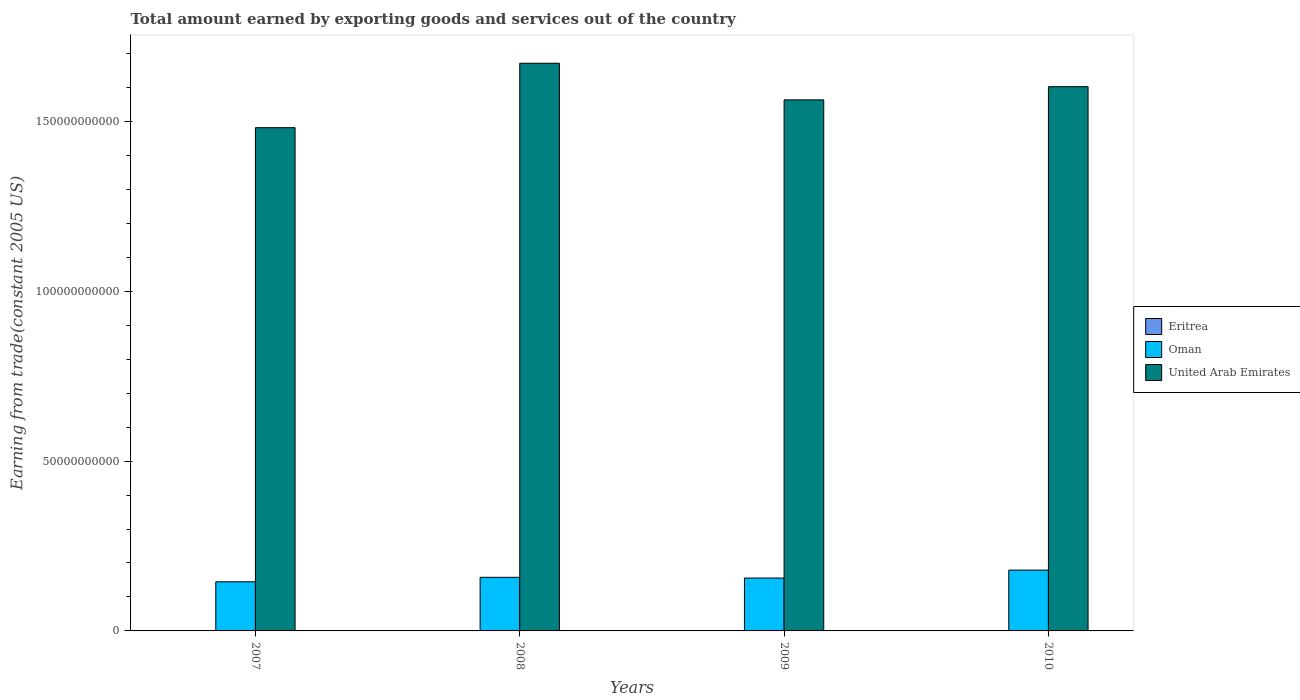How many groups of bars are there?
Offer a very short reply. 4. Are the number of bars per tick equal to the number of legend labels?
Ensure brevity in your answer.  Yes. How many bars are there on the 4th tick from the left?
Ensure brevity in your answer.  3. In how many cases, is the number of bars for a given year not equal to the number of legend labels?
Ensure brevity in your answer.  0. What is the total amount earned by exporting goods and services in United Arab Emirates in 2009?
Offer a terse response. 1.56e+11. Across all years, what is the maximum total amount earned by exporting goods and services in Oman?
Make the answer very short. 1.79e+1. Across all years, what is the minimum total amount earned by exporting goods and services in United Arab Emirates?
Make the answer very short. 1.48e+11. In which year was the total amount earned by exporting goods and services in United Arab Emirates minimum?
Provide a short and direct response. 2007. What is the total total amount earned by exporting goods and services in United Arab Emirates in the graph?
Your answer should be compact. 6.32e+11. What is the difference between the total amount earned by exporting goods and services in Eritrea in 2007 and that in 2008?
Your answer should be compact. 1.45e+07. What is the difference between the total amount earned by exporting goods and services in Oman in 2010 and the total amount earned by exporting goods and services in Eritrea in 2009?
Your answer should be very brief. 1.78e+1. What is the average total amount earned by exporting goods and services in Eritrea per year?
Provide a succinct answer. 6.97e+07. In the year 2009, what is the difference between the total amount earned by exporting goods and services in United Arab Emirates and total amount earned by exporting goods and services in Eritrea?
Your answer should be compact. 1.56e+11. What is the ratio of the total amount earned by exporting goods and services in Oman in 2009 to that in 2010?
Your answer should be very brief. 0.87. Is the total amount earned by exporting goods and services in United Arab Emirates in 2009 less than that in 2010?
Your answer should be compact. Yes. What is the difference between the highest and the second highest total amount earned by exporting goods and services in Eritrea?
Your response must be concise. 1.27e+07. What is the difference between the highest and the lowest total amount earned by exporting goods and services in Eritrea?
Offer a terse response. 3.20e+07. In how many years, is the total amount earned by exporting goods and services in United Arab Emirates greater than the average total amount earned by exporting goods and services in United Arab Emirates taken over all years?
Your response must be concise. 2. What does the 2nd bar from the left in 2009 represents?
Your response must be concise. Oman. What does the 1st bar from the right in 2009 represents?
Ensure brevity in your answer.  United Arab Emirates. How many bars are there?
Give a very brief answer. 12. Are all the bars in the graph horizontal?
Give a very brief answer. No. How many years are there in the graph?
Provide a short and direct response. 4. What is the difference between two consecutive major ticks on the Y-axis?
Ensure brevity in your answer.  5.00e+1. Are the values on the major ticks of Y-axis written in scientific E-notation?
Provide a succinct answer. No. Does the graph contain grids?
Your answer should be compact. No. Where does the legend appear in the graph?
Make the answer very short. Center right. How are the legend labels stacked?
Your answer should be compact. Vertical. What is the title of the graph?
Make the answer very short. Total amount earned by exporting goods and services out of the country. What is the label or title of the X-axis?
Offer a terse response. Years. What is the label or title of the Y-axis?
Provide a succinct answer. Earning from trade(constant 2005 US). What is the Earning from trade(constant 2005 US) of Eritrea in 2007?
Offer a terse response. 6.77e+07. What is the Earning from trade(constant 2005 US) of Oman in 2007?
Provide a succinct answer. 1.45e+1. What is the Earning from trade(constant 2005 US) in United Arab Emirates in 2007?
Your response must be concise. 1.48e+11. What is the Earning from trade(constant 2005 US) in Eritrea in 2008?
Your answer should be compact. 5.32e+07. What is the Earning from trade(constant 2005 US) of Oman in 2008?
Offer a terse response. 1.58e+1. What is the Earning from trade(constant 2005 US) of United Arab Emirates in 2008?
Provide a succinct answer. 1.67e+11. What is the Earning from trade(constant 2005 US) in Eritrea in 2009?
Provide a succinct answer. 7.25e+07. What is the Earning from trade(constant 2005 US) of Oman in 2009?
Provide a short and direct response. 1.56e+1. What is the Earning from trade(constant 2005 US) of United Arab Emirates in 2009?
Offer a terse response. 1.56e+11. What is the Earning from trade(constant 2005 US) in Eritrea in 2010?
Your answer should be very brief. 8.52e+07. What is the Earning from trade(constant 2005 US) of Oman in 2010?
Ensure brevity in your answer.  1.79e+1. What is the Earning from trade(constant 2005 US) in United Arab Emirates in 2010?
Offer a very short reply. 1.60e+11. Across all years, what is the maximum Earning from trade(constant 2005 US) in Eritrea?
Make the answer very short. 8.52e+07. Across all years, what is the maximum Earning from trade(constant 2005 US) in Oman?
Your answer should be compact. 1.79e+1. Across all years, what is the maximum Earning from trade(constant 2005 US) of United Arab Emirates?
Offer a terse response. 1.67e+11. Across all years, what is the minimum Earning from trade(constant 2005 US) of Eritrea?
Your response must be concise. 5.32e+07. Across all years, what is the minimum Earning from trade(constant 2005 US) of Oman?
Your answer should be very brief. 1.45e+1. Across all years, what is the minimum Earning from trade(constant 2005 US) in United Arab Emirates?
Provide a short and direct response. 1.48e+11. What is the total Earning from trade(constant 2005 US) of Eritrea in the graph?
Give a very brief answer. 2.79e+08. What is the total Earning from trade(constant 2005 US) in Oman in the graph?
Your response must be concise. 6.37e+1. What is the total Earning from trade(constant 2005 US) in United Arab Emirates in the graph?
Your response must be concise. 6.32e+11. What is the difference between the Earning from trade(constant 2005 US) of Eritrea in 2007 and that in 2008?
Give a very brief answer. 1.45e+07. What is the difference between the Earning from trade(constant 2005 US) in Oman in 2007 and that in 2008?
Offer a terse response. -1.32e+09. What is the difference between the Earning from trade(constant 2005 US) of United Arab Emirates in 2007 and that in 2008?
Your response must be concise. -1.90e+1. What is the difference between the Earning from trade(constant 2005 US) in Eritrea in 2007 and that in 2009?
Ensure brevity in your answer.  -4.81e+06. What is the difference between the Earning from trade(constant 2005 US) in Oman in 2007 and that in 2009?
Provide a succinct answer. -1.11e+09. What is the difference between the Earning from trade(constant 2005 US) in United Arab Emirates in 2007 and that in 2009?
Your response must be concise. -8.19e+09. What is the difference between the Earning from trade(constant 2005 US) in Eritrea in 2007 and that in 2010?
Provide a succinct answer. -1.75e+07. What is the difference between the Earning from trade(constant 2005 US) in Oman in 2007 and that in 2010?
Give a very brief answer. -3.44e+09. What is the difference between the Earning from trade(constant 2005 US) of United Arab Emirates in 2007 and that in 2010?
Your answer should be compact. -1.21e+1. What is the difference between the Earning from trade(constant 2005 US) of Eritrea in 2008 and that in 2009?
Offer a terse response. -1.93e+07. What is the difference between the Earning from trade(constant 2005 US) of Oman in 2008 and that in 2009?
Make the answer very short. 2.09e+08. What is the difference between the Earning from trade(constant 2005 US) in United Arab Emirates in 2008 and that in 2009?
Your response must be concise. 1.08e+1. What is the difference between the Earning from trade(constant 2005 US) of Eritrea in 2008 and that in 2010?
Keep it short and to the point. -3.20e+07. What is the difference between the Earning from trade(constant 2005 US) of Oman in 2008 and that in 2010?
Provide a succinct answer. -2.12e+09. What is the difference between the Earning from trade(constant 2005 US) in United Arab Emirates in 2008 and that in 2010?
Offer a terse response. 6.90e+09. What is the difference between the Earning from trade(constant 2005 US) of Eritrea in 2009 and that in 2010?
Your response must be concise. -1.27e+07. What is the difference between the Earning from trade(constant 2005 US) in Oman in 2009 and that in 2010?
Your response must be concise. -2.33e+09. What is the difference between the Earning from trade(constant 2005 US) of United Arab Emirates in 2009 and that in 2010?
Your response must be concise. -3.88e+09. What is the difference between the Earning from trade(constant 2005 US) of Eritrea in 2007 and the Earning from trade(constant 2005 US) of Oman in 2008?
Provide a succinct answer. -1.57e+1. What is the difference between the Earning from trade(constant 2005 US) of Eritrea in 2007 and the Earning from trade(constant 2005 US) of United Arab Emirates in 2008?
Offer a terse response. -1.67e+11. What is the difference between the Earning from trade(constant 2005 US) of Oman in 2007 and the Earning from trade(constant 2005 US) of United Arab Emirates in 2008?
Keep it short and to the point. -1.53e+11. What is the difference between the Earning from trade(constant 2005 US) in Eritrea in 2007 and the Earning from trade(constant 2005 US) in Oman in 2009?
Offer a terse response. -1.55e+1. What is the difference between the Earning from trade(constant 2005 US) of Eritrea in 2007 and the Earning from trade(constant 2005 US) of United Arab Emirates in 2009?
Your answer should be compact. -1.56e+11. What is the difference between the Earning from trade(constant 2005 US) of Oman in 2007 and the Earning from trade(constant 2005 US) of United Arab Emirates in 2009?
Provide a short and direct response. -1.42e+11. What is the difference between the Earning from trade(constant 2005 US) in Eritrea in 2007 and the Earning from trade(constant 2005 US) in Oman in 2010?
Your answer should be compact. -1.78e+1. What is the difference between the Earning from trade(constant 2005 US) in Eritrea in 2007 and the Earning from trade(constant 2005 US) in United Arab Emirates in 2010?
Your answer should be very brief. -1.60e+11. What is the difference between the Earning from trade(constant 2005 US) of Oman in 2007 and the Earning from trade(constant 2005 US) of United Arab Emirates in 2010?
Provide a short and direct response. -1.46e+11. What is the difference between the Earning from trade(constant 2005 US) of Eritrea in 2008 and the Earning from trade(constant 2005 US) of Oman in 2009?
Offer a terse response. -1.55e+1. What is the difference between the Earning from trade(constant 2005 US) in Eritrea in 2008 and the Earning from trade(constant 2005 US) in United Arab Emirates in 2009?
Your response must be concise. -1.56e+11. What is the difference between the Earning from trade(constant 2005 US) in Oman in 2008 and the Earning from trade(constant 2005 US) in United Arab Emirates in 2009?
Make the answer very short. -1.41e+11. What is the difference between the Earning from trade(constant 2005 US) in Eritrea in 2008 and the Earning from trade(constant 2005 US) in Oman in 2010?
Ensure brevity in your answer.  -1.78e+1. What is the difference between the Earning from trade(constant 2005 US) of Eritrea in 2008 and the Earning from trade(constant 2005 US) of United Arab Emirates in 2010?
Offer a terse response. -1.60e+11. What is the difference between the Earning from trade(constant 2005 US) of Oman in 2008 and the Earning from trade(constant 2005 US) of United Arab Emirates in 2010?
Keep it short and to the point. -1.44e+11. What is the difference between the Earning from trade(constant 2005 US) of Eritrea in 2009 and the Earning from trade(constant 2005 US) of Oman in 2010?
Provide a succinct answer. -1.78e+1. What is the difference between the Earning from trade(constant 2005 US) in Eritrea in 2009 and the Earning from trade(constant 2005 US) in United Arab Emirates in 2010?
Your answer should be very brief. -1.60e+11. What is the difference between the Earning from trade(constant 2005 US) in Oman in 2009 and the Earning from trade(constant 2005 US) in United Arab Emirates in 2010?
Offer a terse response. -1.45e+11. What is the average Earning from trade(constant 2005 US) in Eritrea per year?
Your response must be concise. 6.97e+07. What is the average Earning from trade(constant 2005 US) of Oman per year?
Your answer should be very brief. 1.59e+1. What is the average Earning from trade(constant 2005 US) in United Arab Emirates per year?
Provide a short and direct response. 1.58e+11. In the year 2007, what is the difference between the Earning from trade(constant 2005 US) of Eritrea and Earning from trade(constant 2005 US) of Oman?
Offer a very short reply. -1.44e+1. In the year 2007, what is the difference between the Earning from trade(constant 2005 US) in Eritrea and Earning from trade(constant 2005 US) in United Arab Emirates?
Keep it short and to the point. -1.48e+11. In the year 2007, what is the difference between the Earning from trade(constant 2005 US) of Oman and Earning from trade(constant 2005 US) of United Arab Emirates?
Provide a short and direct response. -1.34e+11. In the year 2008, what is the difference between the Earning from trade(constant 2005 US) in Eritrea and Earning from trade(constant 2005 US) in Oman?
Keep it short and to the point. -1.57e+1. In the year 2008, what is the difference between the Earning from trade(constant 2005 US) of Eritrea and Earning from trade(constant 2005 US) of United Arab Emirates?
Offer a terse response. -1.67e+11. In the year 2008, what is the difference between the Earning from trade(constant 2005 US) of Oman and Earning from trade(constant 2005 US) of United Arab Emirates?
Give a very brief answer. -1.51e+11. In the year 2009, what is the difference between the Earning from trade(constant 2005 US) in Eritrea and Earning from trade(constant 2005 US) in Oman?
Make the answer very short. -1.55e+1. In the year 2009, what is the difference between the Earning from trade(constant 2005 US) in Eritrea and Earning from trade(constant 2005 US) in United Arab Emirates?
Provide a short and direct response. -1.56e+11. In the year 2009, what is the difference between the Earning from trade(constant 2005 US) in Oman and Earning from trade(constant 2005 US) in United Arab Emirates?
Make the answer very short. -1.41e+11. In the year 2010, what is the difference between the Earning from trade(constant 2005 US) in Eritrea and Earning from trade(constant 2005 US) in Oman?
Keep it short and to the point. -1.78e+1. In the year 2010, what is the difference between the Earning from trade(constant 2005 US) in Eritrea and Earning from trade(constant 2005 US) in United Arab Emirates?
Ensure brevity in your answer.  -1.60e+11. In the year 2010, what is the difference between the Earning from trade(constant 2005 US) in Oman and Earning from trade(constant 2005 US) in United Arab Emirates?
Your response must be concise. -1.42e+11. What is the ratio of the Earning from trade(constant 2005 US) of Eritrea in 2007 to that in 2008?
Your answer should be compact. 1.27. What is the ratio of the Earning from trade(constant 2005 US) of Oman in 2007 to that in 2008?
Ensure brevity in your answer.  0.92. What is the ratio of the Earning from trade(constant 2005 US) of United Arab Emirates in 2007 to that in 2008?
Provide a short and direct response. 0.89. What is the ratio of the Earning from trade(constant 2005 US) of Eritrea in 2007 to that in 2009?
Your answer should be compact. 0.93. What is the ratio of the Earning from trade(constant 2005 US) in Oman in 2007 to that in 2009?
Keep it short and to the point. 0.93. What is the ratio of the Earning from trade(constant 2005 US) of United Arab Emirates in 2007 to that in 2009?
Your answer should be compact. 0.95. What is the ratio of the Earning from trade(constant 2005 US) in Eritrea in 2007 to that in 2010?
Make the answer very short. 0.79. What is the ratio of the Earning from trade(constant 2005 US) of Oman in 2007 to that in 2010?
Give a very brief answer. 0.81. What is the ratio of the Earning from trade(constant 2005 US) of United Arab Emirates in 2007 to that in 2010?
Your answer should be compact. 0.92. What is the ratio of the Earning from trade(constant 2005 US) of Eritrea in 2008 to that in 2009?
Offer a very short reply. 0.73. What is the ratio of the Earning from trade(constant 2005 US) of Oman in 2008 to that in 2009?
Your answer should be compact. 1.01. What is the ratio of the Earning from trade(constant 2005 US) of United Arab Emirates in 2008 to that in 2009?
Provide a short and direct response. 1.07. What is the ratio of the Earning from trade(constant 2005 US) in Eritrea in 2008 to that in 2010?
Ensure brevity in your answer.  0.62. What is the ratio of the Earning from trade(constant 2005 US) of Oman in 2008 to that in 2010?
Ensure brevity in your answer.  0.88. What is the ratio of the Earning from trade(constant 2005 US) of United Arab Emirates in 2008 to that in 2010?
Your answer should be very brief. 1.04. What is the ratio of the Earning from trade(constant 2005 US) in Eritrea in 2009 to that in 2010?
Keep it short and to the point. 0.85. What is the ratio of the Earning from trade(constant 2005 US) of Oman in 2009 to that in 2010?
Ensure brevity in your answer.  0.87. What is the ratio of the Earning from trade(constant 2005 US) of United Arab Emirates in 2009 to that in 2010?
Offer a very short reply. 0.98. What is the difference between the highest and the second highest Earning from trade(constant 2005 US) of Eritrea?
Provide a short and direct response. 1.27e+07. What is the difference between the highest and the second highest Earning from trade(constant 2005 US) of Oman?
Provide a succinct answer. 2.12e+09. What is the difference between the highest and the second highest Earning from trade(constant 2005 US) of United Arab Emirates?
Your response must be concise. 6.90e+09. What is the difference between the highest and the lowest Earning from trade(constant 2005 US) of Eritrea?
Keep it short and to the point. 3.20e+07. What is the difference between the highest and the lowest Earning from trade(constant 2005 US) in Oman?
Your answer should be compact. 3.44e+09. What is the difference between the highest and the lowest Earning from trade(constant 2005 US) in United Arab Emirates?
Keep it short and to the point. 1.90e+1. 